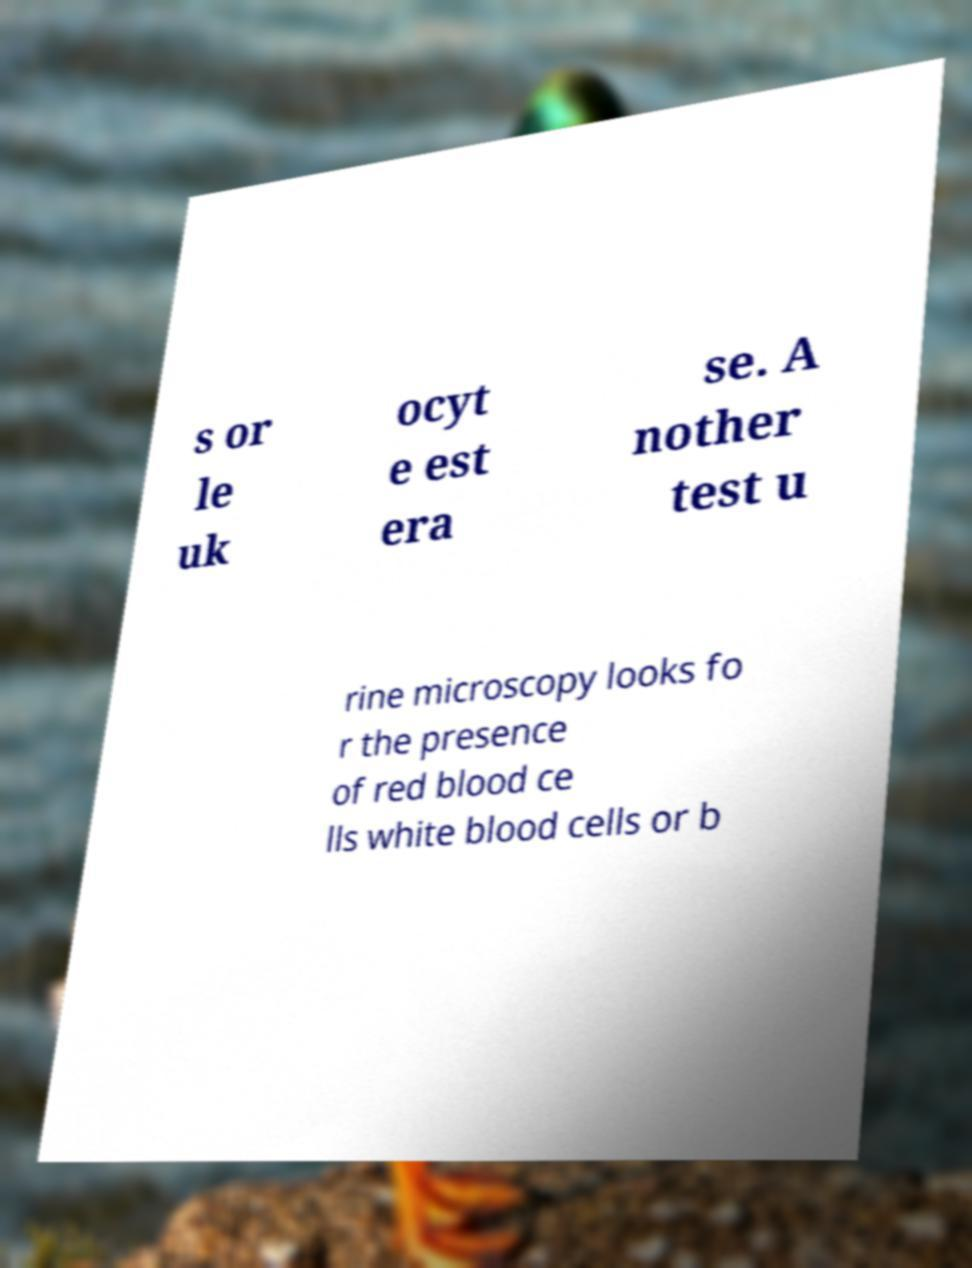What messages or text are displayed in this image? I need them in a readable, typed format. s or le uk ocyt e est era se. A nother test u rine microscopy looks fo r the presence of red blood ce lls white blood cells or b 